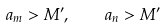Convert formula to latex. <formula><loc_0><loc_0><loc_500><loc_500>a _ { m } > M ^ { \prime } , \quad a _ { n } > M ^ { \prime }</formula> 